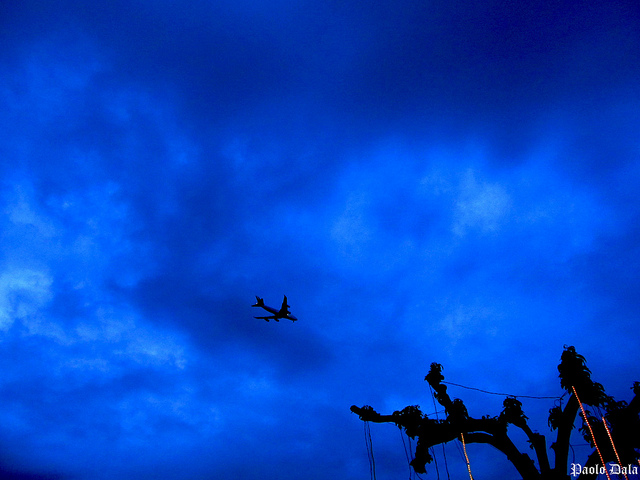<image>Is this an ocean or a lake? It is ambiguous whether this is an ocean or a lake. It may neither be an ocean or a lake. Is this an ocean or a lake? I don't know if this is an ocean or a lake. It can be seen as both a lake and the sky. 